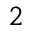<formula> <loc_0><loc_0><loc_500><loc_500>_ { 2 }</formula> 